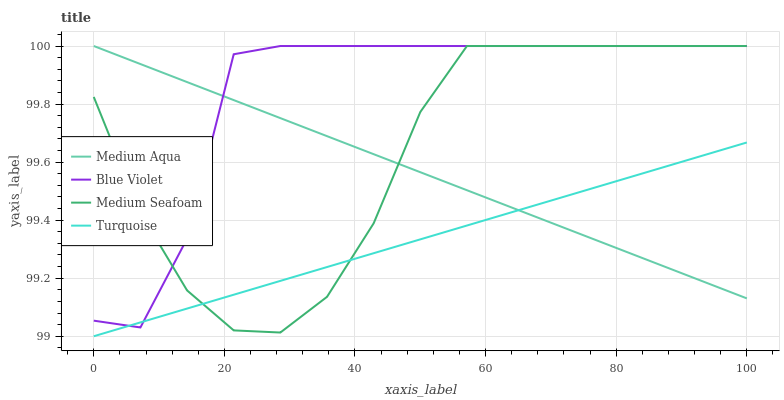Does Turquoise have the minimum area under the curve?
Answer yes or no. Yes. Does Blue Violet have the maximum area under the curve?
Answer yes or no. Yes. Does Medium Aqua have the minimum area under the curve?
Answer yes or no. No. Does Medium Aqua have the maximum area under the curve?
Answer yes or no. No. Is Turquoise the smoothest?
Answer yes or no. Yes. Is Blue Violet the roughest?
Answer yes or no. Yes. Is Medium Aqua the smoothest?
Answer yes or no. No. Is Medium Aqua the roughest?
Answer yes or no. No. Does Medium Seafoam have the lowest value?
Answer yes or no. No. Does Blue Violet have the highest value?
Answer yes or no. Yes. Does Medium Seafoam intersect Medium Aqua?
Answer yes or no. Yes. Is Medium Seafoam less than Medium Aqua?
Answer yes or no. No. Is Medium Seafoam greater than Medium Aqua?
Answer yes or no. No. 